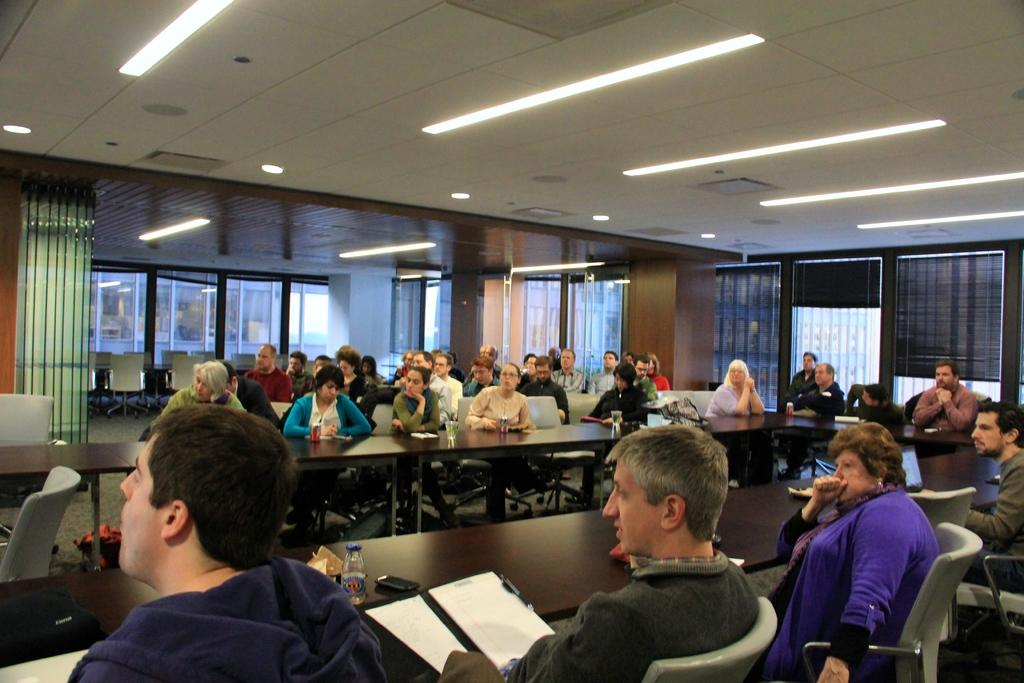What are the people in the image doing? The people in the image are sitting on chairs. Where are the chairs located in relation to other objects? The chairs are near a table. What can be seen in the background of the image? There are glass windows and doors in the background of the image. What is present on the ceiling in the image? The ceiling in the image has lights. What type of meal is being served to the people in the image? There is no meal present in the image; it only shows people sitting on chairs near a table. What kind of pain is the person in the image experiencing? There is no indication of pain or any medical condition in the image; it only shows people sitting on chairs near a table. 